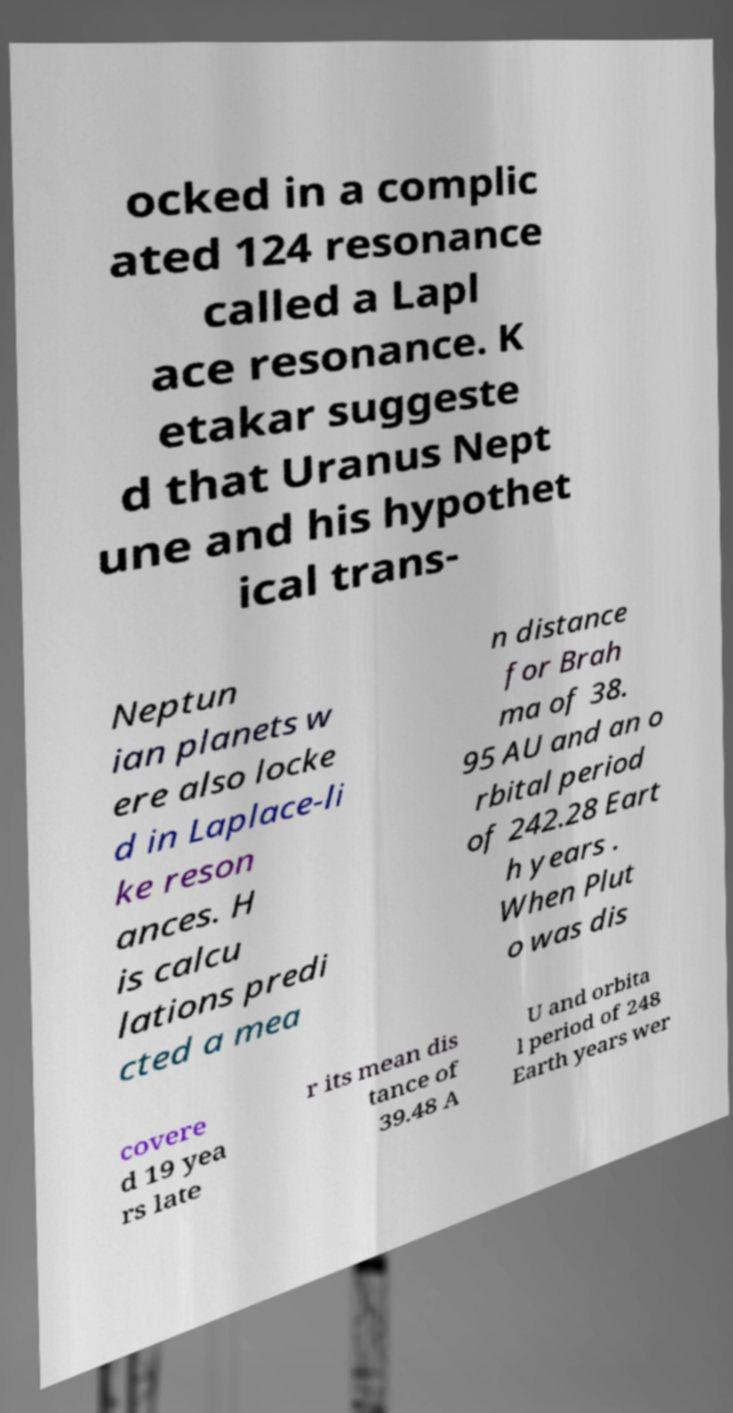Can you read and provide the text displayed in the image?This photo seems to have some interesting text. Can you extract and type it out for me? ocked in a complic ated 124 resonance called a Lapl ace resonance. K etakar suggeste d that Uranus Nept une and his hypothet ical trans- Neptun ian planets w ere also locke d in Laplace-li ke reson ances. H is calcu lations predi cted a mea n distance for Brah ma of 38. 95 AU and an o rbital period of 242.28 Eart h years . When Plut o was dis covere d 19 yea rs late r its mean dis tance of 39.48 A U and orbita l period of 248 Earth years wer 